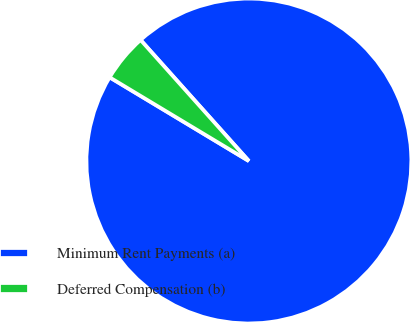Convert chart. <chart><loc_0><loc_0><loc_500><loc_500><pie_chart><fcel>Minimum Rent Payments (a)<fcel>Deferred Compensation (b)<nl><fcel>95.23%<fcel>4.77%<nl></chart> 